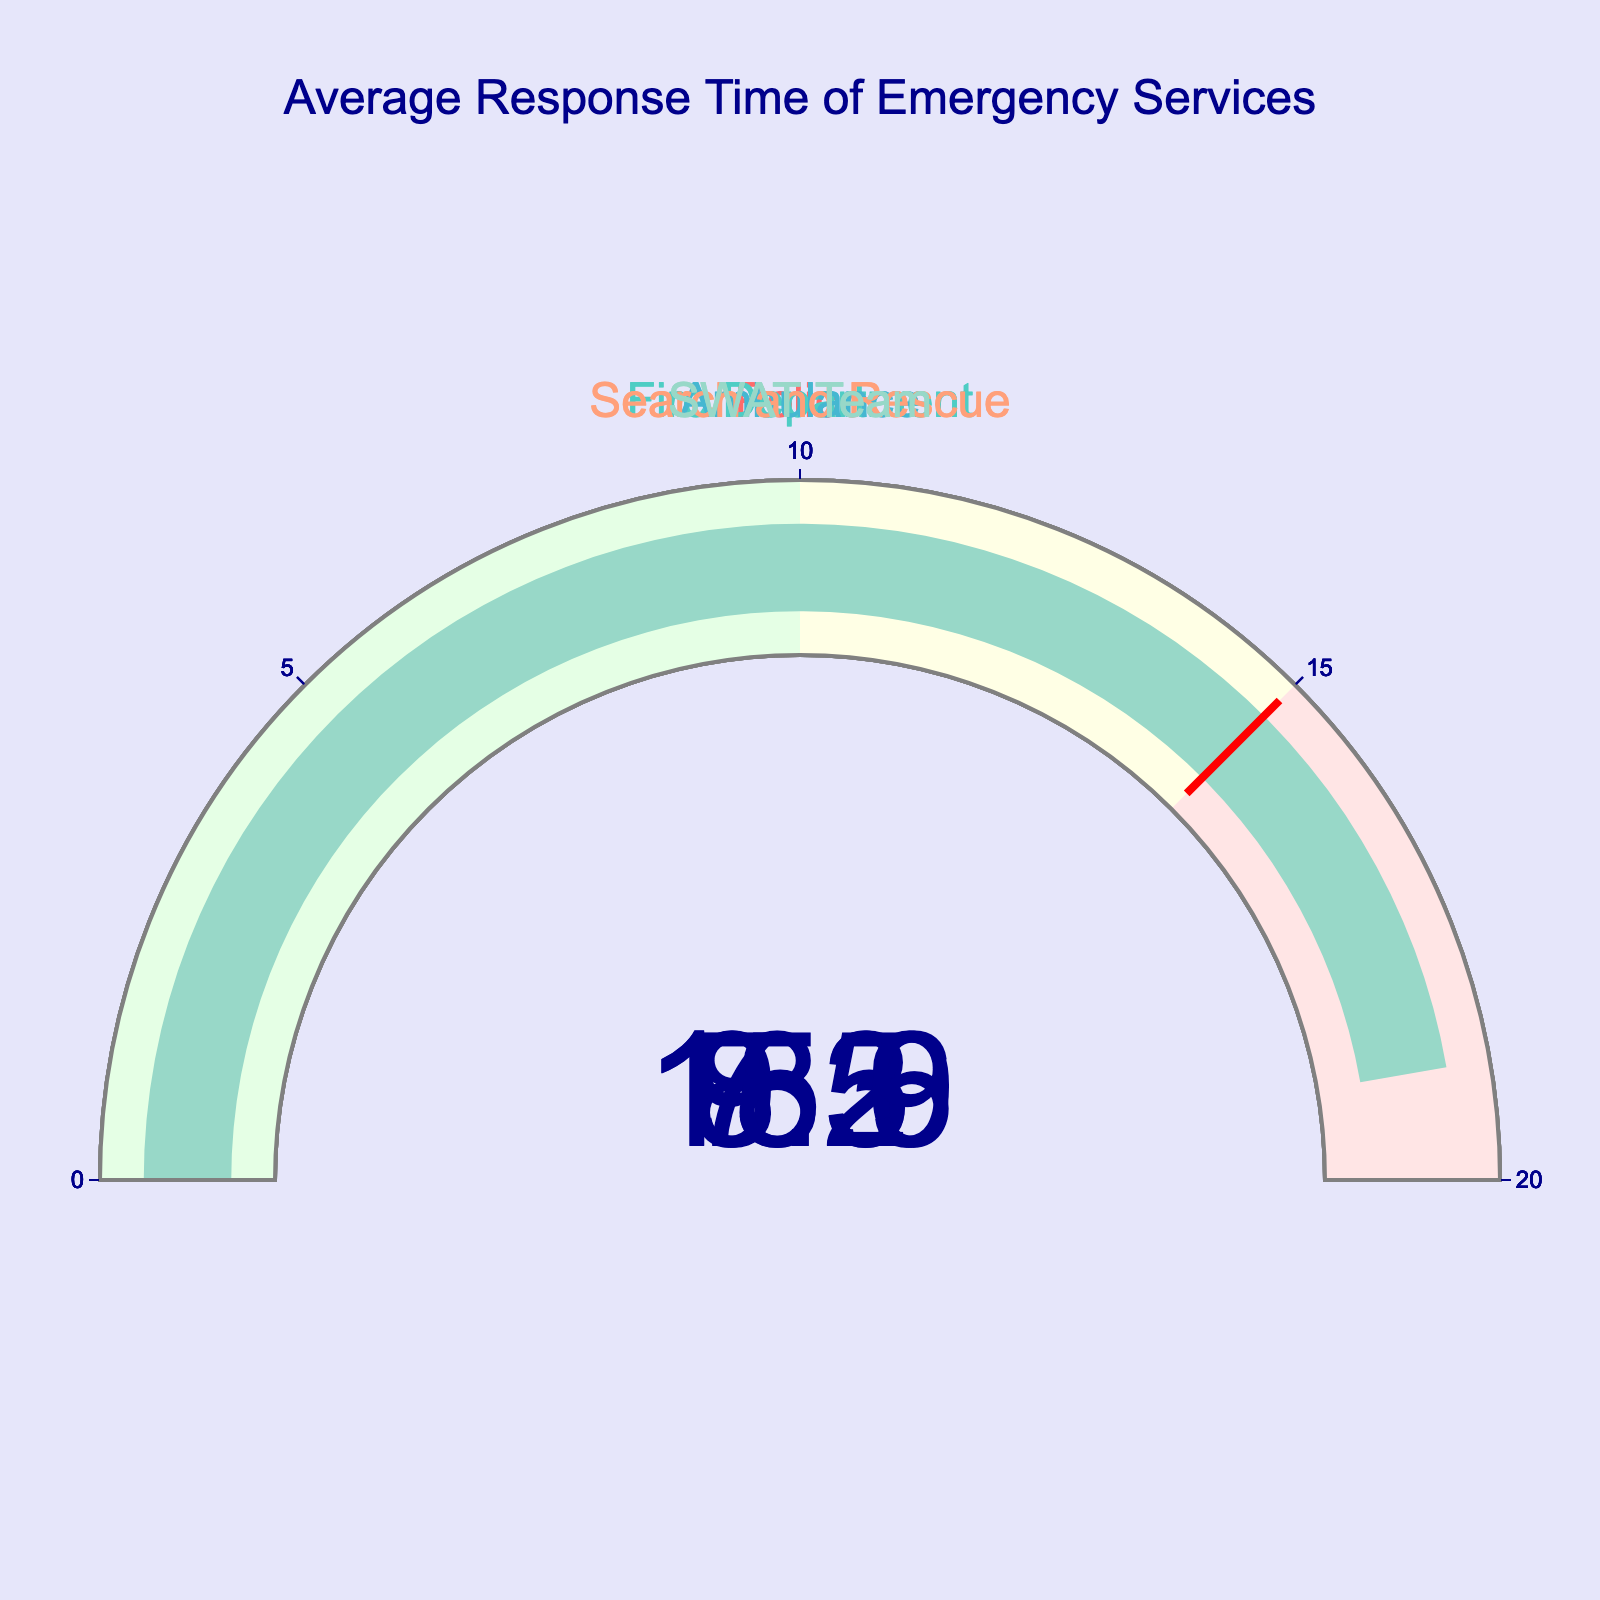What's the average response time of all emergency services? The response times are 8.5, 7.2, 9.3, 15.6, and 18.9. Adding them gives 59.5, and dividing by the number of services (5) gives 59.5 / 5.
Answer: 11.9 Which emergency service has the fastest response time? Comparing the values on the gauge charts, the Fire Department has the lowest response time at 7.2 minutes.
Answer: Fire Department Which emergency service has the slowest response time? By looking at the gauge charts, the SWAT Team has the highest response time at 18.9 minutes.
Answer: SWAT Team How much longer does it take for the SWAT Team to respond compared to the Police? The SWAT Team's response time is 18.9 minutes, and the Police's response time is 8.5 minutes. So, the difference is 18.9 - 8.5.
Answer: 10.4 Are any of the response times above 15 minutes? Based on the gauge charts, both the Search and Rescue and SWAT Team have response times above 15 minutes.
Answer: Yes Which services fall within the 0-10 minute range based on the gauges? The gauge indicating ranges shows that Police, Fire Department, and Ambulance have response times in the 0-10 minute range.
Answer: Police, Fire Department, Ambulance What is the combined response time of the Fire Department and Ambulance? Summing the two response times of the Fire Department (7.2) and Ambulance (9.3) gives 7.2 + 9.3.
Answer: 16.5 By how much does the Police response time exceed that of the Fire Department? The Police's response time is 8.5 minutes, and the Fire Department's is 7.2 minutes. The difference is 8.5 - 7.2.
Answer: 1.3 What proportion of the services have a response time greater than the overall average? The overall average response time is 11.9 minutes. The Search and Rescue (15.6) and SWAT Team (18.9) have response times greater than 11.9. There are 5 services in total, so the proportion is 2/5.
Answer: 0.4 (or 40%) 